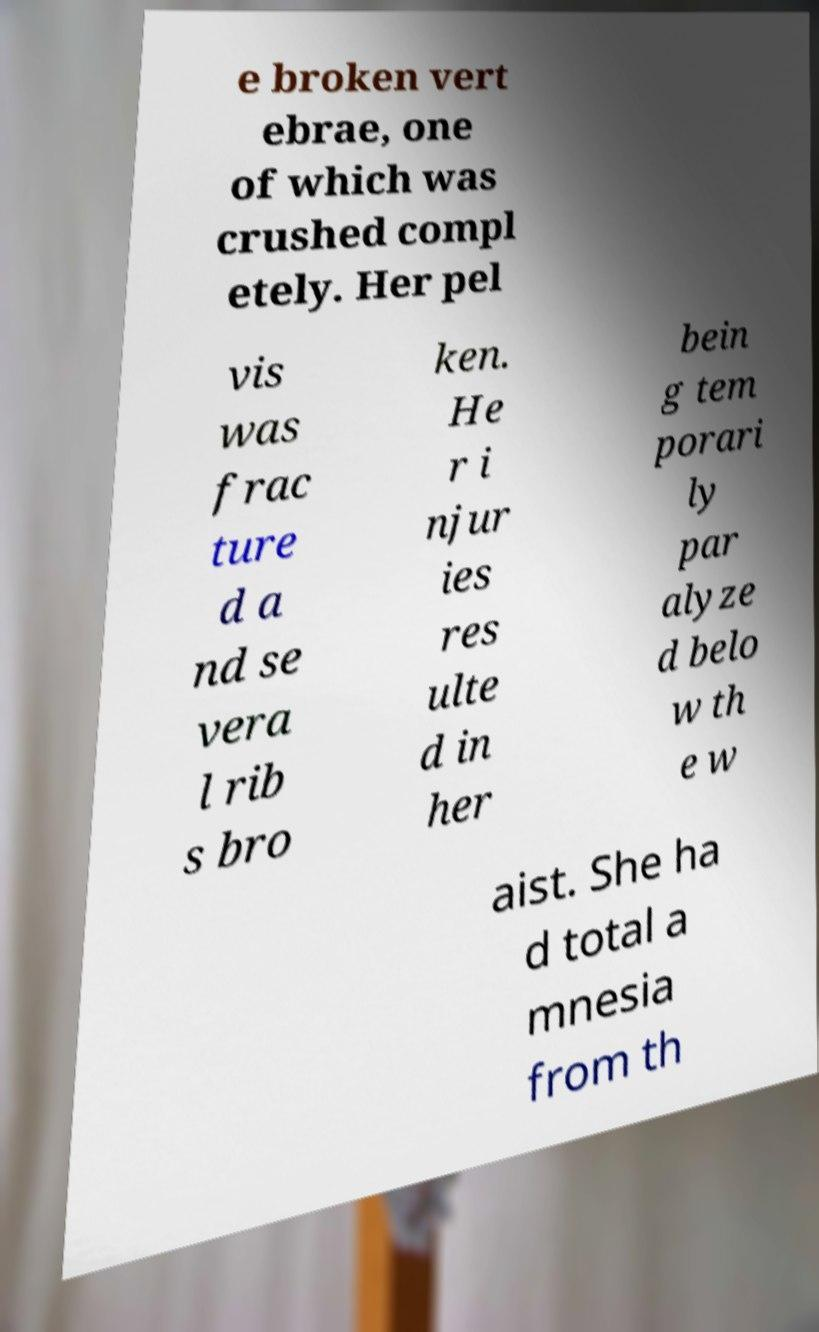Can you accurately transcribe the text from the provided image for me? e broken vert ebrae, one of which was crushed compl etely. Her pel vis was frac ture d a nd se vera l rib s bro ken. He r i njur ies res ulte d in her bein g tem porari ly par alyze d belo w th e w aist. She ha d total a mnesia from th 